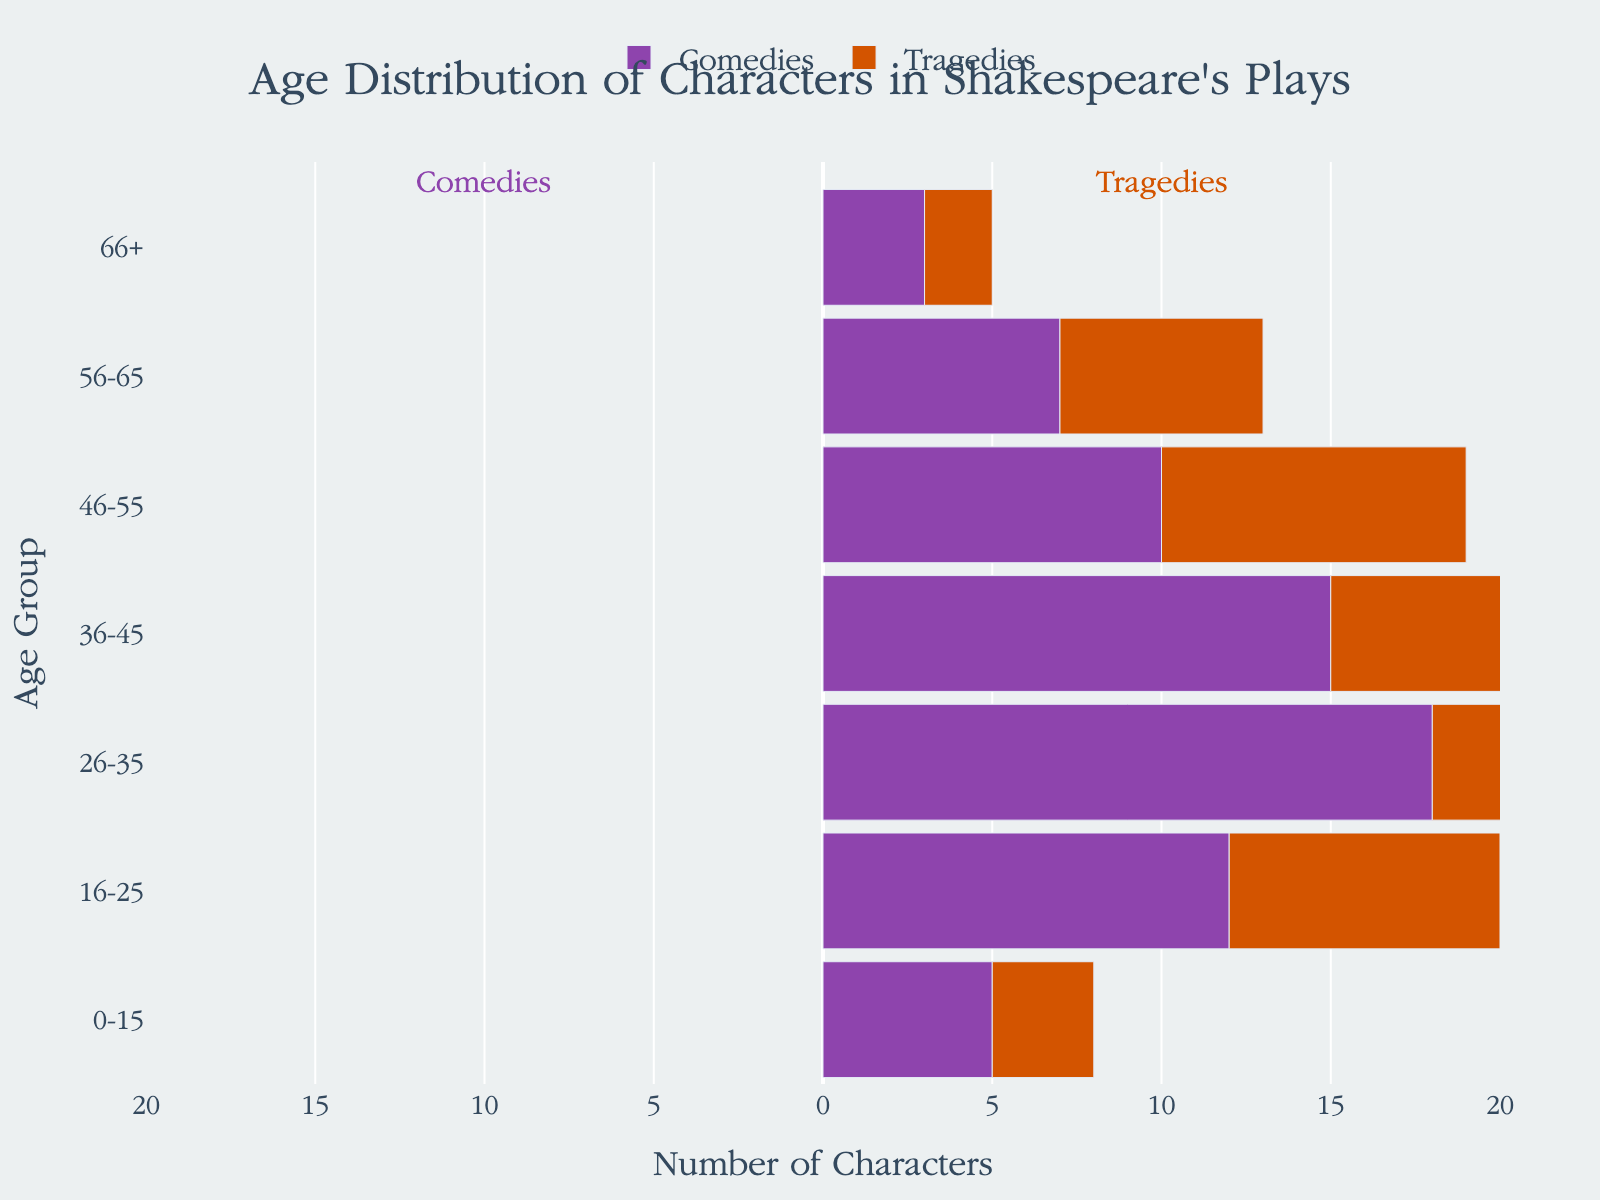What is the title of the plot? The title of the plot is usually displayed at the top center of the figure in larger font size. Here, it reads 'Age Distribution of Characters in Shakespeare's Plays'.
Answer: Age Distribution of Characters in Shakespeare's Plays How many age groups are considered in the plot? Each horizontal bar corresponds to an age group. By counting these bars, we can determine the number of age groups. Here, there are seven bars listed as 0-15, 16-25, 26-35, 36-45, 46-55, 56-65, and 66+.
Answer: Seven Which age group has the highest number of characters in tragedies? By examining the bars on the right-hand side (representing tragedies), the longest bar indicates the largest value. The 26-35 age group has the longest bar with a value of 15.
Answer: 26-35 Are there more characters aged 16-25 in comedies or tragedies? To answer this, compare the lengths of the bars for the 16-25 age group on both sides of the pyramid. The comedies bar extends to -12, while the tragedies bar extends to 8. The negative value indicates comedies.
Answer: Comedies What is the total number of characters aged 36-45 across both genres? Sum the absolute values of the numbers for the 36-45 age group. In comedies, this is 15, and in tragedies, it is 12, making the total 15 + 12 = 27.
Answer: 27 What is the least populated age group in comedies? By examining the lengths of bars on the left-hand side (comedies), the shortest bar corresponds to the age group with the lowest number of characters. The 66+ age group has the shortest bar with a value of -3.
Answer: 66+ Which genre has a more even distribution of characters across different age groups? Compare the distribution of bar lengths on both sides. Comedies have a more even distribution as the values (-5, -12, -18, -15, -10, -7, -3) are closer together compared to the values for tragedies (3, 8, 15, 12, 9, 6, 2).
Answer: Comedies Do more characters fall under the category of 26-35 or 46-55 in tragedies? By comparing the bars for these two age groups on the right-hand side, the 26-35 age group bar (15) is longer compared to the 46-55 bar (9), indicating more characters in the 26-35 age group.
Answer: 26-35 